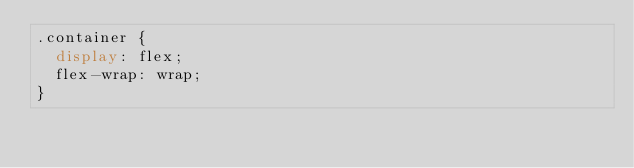Convert code to text. <code><loc_0><loc_0><loc_500><loc_500><_CSS_>.container {
  display: flex;
  flex-wrap: wrap;
}</code> 